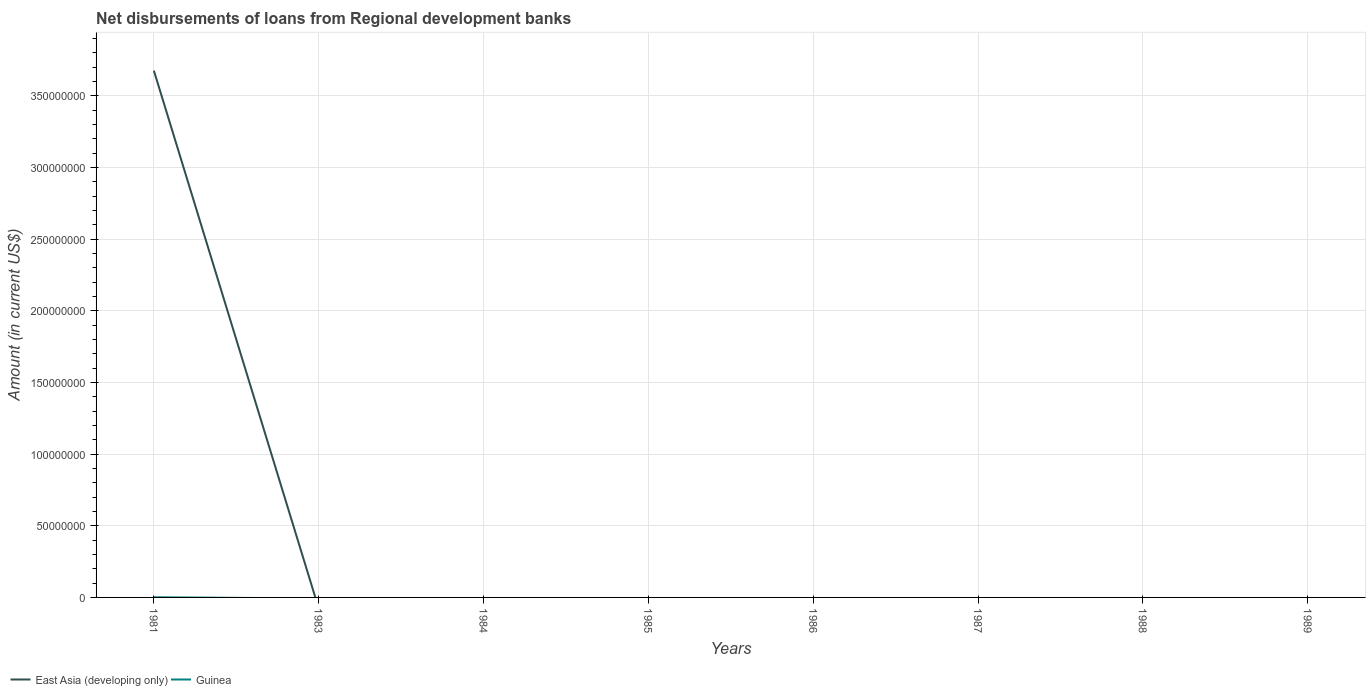Does the line corresponding to Guinea intersect with the line corresponding to East Asia (developing only)?
Offer a terse response. Yes. Across all years, what is the maximum amount of disbursements of loans from regional development banks in East Asia (developing only)?
Make the answer very short. 0. What is the difference between the highest and the second highest amount of disbursements of loans from regional development banks in Guinea?
Provide a succinct answer. 1.07e+05. What is the difference between the highest and the lowest amount of disbursements of loans from regional development banks in East Asia (developing only)?
Make the answer very short. 1. How many years are there in the graph?
Offer a very short reply. 8. What is the difference between two consecutive major ticks on the Y-axis?
Your response must be concise. 5.00e+07. Where does the legend appear in the graph?
Ensure brevity in your answer.  Bottom left. How many legend labels are there?
Keep it short and to the point. 2. What is the title of the graph?
Make the answer very short. Net disbursements of loans from Regional development banks. Does "Germany" appear as one of the legend labels in the graph?
Provide a succinct answer. No. What is the label or title of the X-axis?
Your response must be concise. Years. What is the Amount (in current US$) of East Asia (developing only) in 1981?
Provide a short and direct response. 3.68e+08. What is the Amount (in current US$) in Guinea in 1981?
Your response must be concise. 1.07e+05. What is the Amount (in current US$) in East Asia (developing only) in 1983?
Offer a terse response. 0. What is the Amount (in current US$) of Guinea in 1983?
Provide a short and direct response. 0. What is the Amount (in current US$) of East Asia (developing only) in 1984?
Ensure brevity in your answer.  0. What is the Amount (in current US$) in Guinea in 1986?
Give a very brief answer. 0. What is the Amount (in current US$) of East Asia (developing only) in 1987?
Your answer should be compact. 0. What is the Amount (in current US$) of Guinea in 1987?
Your answer should be compact. 0. What is the Amount (in current US$) in East Asia (developing only) in 1988?
Provide a short and direct response. 0. What is the Amount (in current US$) of Guinea in 1988?
Offer a terse response. 0. What is the Amount (in current US$) in East Asia (developing only) in 1989?
Make the answer very short. 0. What is the Amount (in current US$) in Guinea in 1989?
Your answer should be very brief. 0. Across all years, what is the maximum Amount (in current US$) of East Asia (developing only)?
Make the answer very short. 3.68e+08. Across all years, what is the maximum Amount (in current US$) in Guinea?
Provide a succinct answer. 1.07e+05. Across all years, what is the minimum Amount (in current US$) in East Asia (developing only)?
Provide a succinct answer. 0. What is the total Amount (in current US$) of East Asia (developing only) in the graph?
Your answer should be compact. 3.68e+08. What is the total Amount (in current US$) in Guinea in the graph?
Your answer should be very brief. 1.07e+05. What is the average Amount (in current US$) of East Asia (developing only) per year?
Make the answer very short. 4.59e+07. What is the average Amount (in current US$) of Guinea per year?
Keep it short and to the point. 1.34e+04. In the year 1981, what is the difference between the Amount (in current US$) of East Asia (developing only) and Amount (in current US$) of Guinea?
Make the answer very short. 3.67e+08. What is the difference between the highest and the lowest Amount (in current US$) of East Asia (developing only)?
Provide a succinct answer. 3.68e+08. What is the difference between the highest and the lowest Amount (in current US$) in Guinea?
Ensure brevity in your answer.  1.07e+05. 